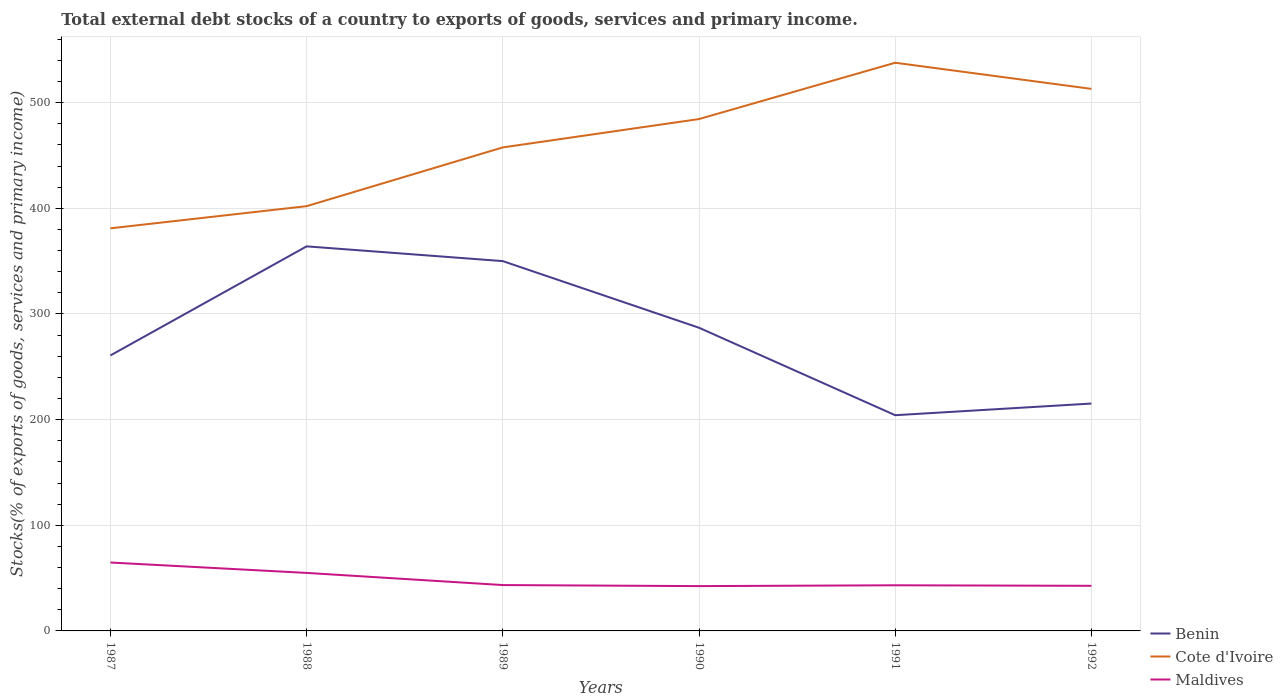How many different coloured lines are there?
Your answer should be compact. 3. Across all years, what is the maximum total debt stocks in Maldives?
Offer a very short reply. 42.42. In which year was the total debt stocks in Cote d'Ivoire maximum?
Ensure brevity in your answer.  1987. What is the total total debt stocks in Maldives in the graph?
Keep it short and to the point. -0.28. What is the difference between the highest and the second highest total debt stocks in Maldives?
Make the answer very short. 22.32. What is the difference between the highest and the lowest total debt stocks in Benin?
Offer a very short reply. 3. Is the total debt stocks in Maldives strictly greater than the total debt stocks in Cote d'Ivoire over the years?
Make the answer very short. Yes. How many lines are there?
Your answer should be compact. 3. Are the values on the major ticks of Y-axis written in scientific E-notation?
Offer a terse response. No. Does the graph contain any zero values?
Your response must be concise. No. Does the graph contain grids?
Give a very brief answer. Yes. Where does the legend appear in the graph?
Your response must be concise. Bottom right. How many legend labels are there?
Ensure brevity in your answer.  3. How are the legend labels stacked?
Offer a terse response. Vertical. What is the title of the graph?
Keep it short and to the point. Total external debt stocks of a country to exports of goods, services and primary income. What is the label or title of the Y-axis?
Make the answer very short. Stocks(% of exports of goods, services and primary income). What is the Stocks(% of exports of goods, services and primary income) of Benin in 1987?
Make the answer very short. 260.75. What is the Stocks(% of exports of goods, services and primary income) of Cote d'Ivoire in 1987?
Your answer should be very brief. 381.06. What is the Stocks(% of exports of goods, services and primary income) in Maldives in 1987?
Offer a very short reply. 64.74. What is the Stocks(% of exports of goods, services and primary income) in Benin in 1988?
Your answer should be very brief. 363.97. What is the Stocks(% of exports of goods, services and primary income) in Cote d'Ivoire in 1988?
Provide a succinct answer. 402.02. What is the Stocks(% of exports of goods, services and primary income) of Maldives in 1988?
Ensure brevity in your answer.  54.9. What is the Stocks(% of exports of goods, services and primary income) of Benin in 1989?
Offer a terse response. 350.01. What is the Stocks(% of exports of goods, services and primary income) in Cote d'Ivoire in 1989?
Keep it short and to the point. 457.64. What is the Stocks(% of exports of goods, services and primary income) in Maldives in 1989?
Offer a terse response. 43.4. What is the Stocks(% of exports of goods, services and primary income) in Benin in 1990?
Your response must be concise. 286.95. What is the Stocks(% of exports of goods, services and primary income) in Cote d'Ivoire in 1990?
Keep it short and to the point. 484.46. What is the Stocks(% of exports of goods, services and primary income) of Maldives in 1990?
Offer a terse response. 42.42. What is the Stocks(% of exports of goods, services and primary income) of Benin in 1991?
Make the answer very short. 204.17. What is the Stocks(% of exports of goods, services and primary income) in Cote d'Ivoire in 1991?
Provide a succinct answer. 537.76. What is the Stocks(% of exports of goods, services and primary income) of Maldives in 1991?
Keep it short and to the point. 43.2. What is the Stocks(% of exports of goods, services and primary income) in Benin in 1992?
Keep it short and to the point. 215.21. What is the Stocks(% of exports of goods, services and primary income) in Cote d'Ivoire in 1992?
Give a very brief answer. 513.04. What is the Stocks(% of exports of goods, services and primary income) in Maldives in 1992?
Make the answer very short. 42.7. Across all years, what is the maximum Stocks(% of exports of goods, services and primary income) of Benin?
Provide a succinct answer. 363.97. Across all years, what is the maximum Stocks(% of exports of goods, services and primary income) of Cote d'Ivoire?
Your answer should be compact. 537.76. Across all years, what is the maximum Stocks(% of exports of goods, services and primary income) in Maldives?
Make the answer very short. 64.74. Across all years, what is the minimum Stocks(% of exports of goods, services and primary income) in Benin?
Offer a very short reply. 204.17. Across all years, what is the minimum Stocks(% of exports of goods, services and primary income) of Cote d'Ivoire?
Give a very brief answer. 381.06. Across all years, what is the minimum Stocks(% of exports of goods, services and primary income) in Maldives?
Provide a short and direct response. 42.42. What is the total Stocks(% of exports of goods, services and primary income) of Benin in the graph?
Your response must be concise. 1681.06. What is the total Stocks(% of exports of goods, services and primary income) in Cote d'Ivoire in the graph?
Provide a succinct answer. 2775.98. What is the total Stocks(% of exports of goods, services and primary income) of Maldives in the graph?
Keep it short and to the point. 291.36. What is the difference between the Stocks(% of exports of goods, services and primary income) of Benin in 1987 and that in 1988?
Make the answer very short. -103.22. What is the difference between the Stocks(% of exports of goods, services and primary income) in Cote d'Ivoire in 1987 and that in 1988?
Your answer should be compact. -20.96. What is the difference between the Stocks(% of exports of goods, services and primary income) of Maldives in 1987 and that in 1988?
Make the answer very short. 9.83. What is the difference between the Stocks(% of exports of goods, services and primary income) in Benin in 1987 and that in 1989?
Ensure brevity in your answer.  -89.26. What is the difference between the Stocks(% of exports of goods, services and primary income) of Cote d'Ivoire in 1987 and that in 1989?
Provide a succinct answer. -76.58. What is the difference between the Stocks(% of exports of goods, services and primary income) of Maldives in 1987 and that in 1989?
Your response must be concise. 21.33. What is the difference between the Stocks(% of exports of goods, services and primary income) in Benin in 1987 and that in 1990?
Provide a short and direct response. -26.19. What is the difference between the Stocks(% of exports of goods, services and primary income) of Cote d'Ivoire in 1987 and that in 1990?
Give a very brief answer. -103.4. What is the difference between the Stocks(% of exports of goods, services and primary income) in Maldives in 1987 and that in 1990?
Offer a terse response. 22.32. What is the difference between the Stocks(% of exports of goods, services and primary income) of Benin in 1987 and that in 1991?
Offer a very short reply. 56.58. What is the difference between the Stocks(% of exports of goods, services and primary income) of Cote d'Ivoire in 1987 and that in 1991?
Ensure brevity in your answer.  -156.7. What is the difference between the Stocks(% of exports of goods, services and primary income) in Maldives in 1987 and that in 1991?
Offer a terse response. 21.54. What is the difference between the Stocks(% of exports of goods, services and primary income) of Benin in 1987 and that in 1992?
Your answer should be very brief. 45.55. What is the difference between the Stocks(% of exports of goods, services and primary income) of Cote d'Ivoire in 1987 and that in 1992?
Offer a very short reply. -131.98. What is the difference between the Stocks(% of exports of goods, services and primary income) of Maldives in 1987 and that in 1992?
Your response must be concise. 22.04. What is the difference between the Stocks(% of exports of goods, services and primary income) in Benin in 1988 and that in 1989?
Make the answer very short. 13.96. What is the difference between the Stocks(% of exports of goods, services and primary income) of Cote d'Ivoire in 1988 and that in 1989?
Make the answer very short. -55.62. What is the difference between the Stocks(% of exports of goods, services and primary income) of Maldives in 1988 and that in 1989?
Your answer should be compact. 11.5. What is the difference between the Stocks(% of exports of goods, services and primary income) in Benin in 1988 and that in 1990?
Your answer should be very brief. 77.02. What is the difference between the Stocks(% of exports of goods, services and primary income) of Cote d'Ivoire in 1988 and that in 1990?
Your answer should be very brief. -82.44. What is the difference between the Stocks(% of exports of goods, services and primary income) of Maldives in 1988 and that in 1990?
Ensure brevity in your answer.  12.48. What is the difference between the Stocks(% of exports of goods, services and primary income) in Benin in 1988 and that in 1991?
Your answer should be compact. 159.8. What is the difference between the Stocks(% of exports of goods, services and primary income) in Cote d'Ivoire in 1988 and that in 1991?
Ensure brevity in your answer.  -135.74. What is the difference between the Stocks(% of exports of goods, services and primary income) of Maldives in 1988 and that in 1991?
Offer a very short reply. 11.71. What is the difference between the Stocks(% of exports of goods, services and primary income) in Benin in 1988 and that in 1992?
Keep it short and to the point. 148.76. What is the difference between the Stocks(% of exports of goods, services and primary income) of Cote d'Ivoire in 1988 and that in 1992?
Offer a terse response. -111.02. What is the difference between the Stocks(% of exports of goods, services and primary income) of Maldives in 1988 and that in 1992?
Your answer should be very brief. 12.21. What is the difference between the Stocks(% of exports of goods, services and primary income) of Benin in 1989 and that in 1990?
Ensure brevity in your answer.  63.06. What is the difference between the Stocks(% of exports of goods, services and primary income) of Cote d'Ivoire in 1989 and that in 1990?
Keep it short and to the point. -26.83. What is the difference between the Stocks(% of exports of goods, services and primary income) in Maldives in 1989 and that in 1990?
Ensure brevity in your answer.  0.98. What is the difference between the Stocks(% of exports of goods, services and primary income) of Benin in 1989 and that in 1991?
Offer a very short reply. 145.84. What is the difference between the Stocks(% of exports of goods, services and primary income) in Cote d'Ivoire in 1989 and that in 1991?
Give a very brief answer. -80.12. What is the difference between the Stocks(% of exports of goods, services and primary income) of Maldives in 1989 and that in 1991?
Offer a very short reply. 0.2. What is the difference between the Stocks(% of exports of goods, services and primary income) in Benin in 1989 and that in 1992?
Provide a short and direct response. 134.8. What is the difference between the Stocks(% of exports of goods, services and primary income) of Cote d'Ivoire in 1989 and that in 1992?
Provide a short and direct response. -55.4. What is the difference between the Stocks(% of exports of goods, services and primary income) of Maldives in 1989 and that in 1992?
Make the answer very short. 0.71. What is the difference between the Stocks(% of exports of goods, services and primary income) in Benin in 1990 and that in 1991?
Your answer should be very brief. 82.78. What is the difference between the Stocks(% of exports of goods, services and primary income) of Cote d'Ivoire in 1990 and that in 1991?
Your response must be concise. -53.3. What is the difference between the Stocks(% of exports of goods, services and primary income) of Maldives in 1990 and that in 1991?
Offer a very short reply. -0.78. What is the difference between the Stocks(% of exports of goods, services and primary income) in Benin in 1990 and that in 1992?
Your response must be concise. 71.74. What is the difference between the Stocks(% of exports of goods, services and primary income) of Cote d'Ivoire in 1990 and that in 1992?
Your answer should be compact. -28.57. What is the difference between the Stocks(% of exports of goods, services and primary income) in Maldives in 1990 and that in 1992?
Ensure brevity in your answer.  -0.28. What is the difference between the Stocks(% of exports of goods, services and primary income) of Benin in 1991 and that in 1992?
Your response must be concise. -11.04. What is the difference between the Stocks(% of exports of goods, services and primary income) of Cote d'Ivoire in 1991 and that in 1992?
Provide a short and direct response. 24.72. What is the difference between the Stocks(% of exports of goods, services and primary income) of Maldives in 1991 and that in 1992?
Give a very brief answer. 0.5. What is the difference between the Stocks(% of exports of goods, services and primary income) in Benin in 1987 and the Stocks(% of exports of goods, services and primary income) in Cote d'Ivoire in 1988?
Offer a very short reply. -141.27. What is the difference between the Stocks(% of exports of goods, services and primary income) in Benin in 1987 and the Stocks(% of exports of goods, services and primary income) in Maldives in 1988?
Give a very brief answer. 205.85. What is the difference between the Stocks(% of exports of goods, services and primary income) of Cote d'Ivoire in 1987 and the Stocks(% of exports of goods, services and primary income) of Maldives in 1988?
Your response must be concise. 326.16. What is the difference between the Stocks(% of exports of goods, services and primary income) in Benin in 1987 and the Stocks(% of exports of goods, services and primary income) in Cote d'Ivoire in 1989?
Give a very brief answer. -196.88. What is the difference between the Stocks(% of exports of goods, services and primary income) in Benin in 1987 and the Stocks(% of exports of goods, services and primary income) in Maldives in 1989?
Offer a terse response. 217.35. What is the difference between the Stocks(% of exports of goods, services and primary income) of Cote d'Ivoire in 1987 and the Stocks(% of exports of goods, services and primary income) of Maldives in 1989?
Make the answer very short. 337.66. What is the difference between the Stocks(% of exports of goods, services and primary income) in Benin in 1987 and the Stocks(% of exports of goods, services and primary income) in Cote d'Ivoire in 1990?
Keep it short and to the point. -223.71. What is the difference between the Stocks(% of exports of goods, services and primary income) of Benin in 1987 and the Stocks(% of exports of goods, services and primary income) of Maldives in 1990?
Provide a short and direct response. 218.33. What is the difference between the Stocks(% of exports of goods, services and primary income) of Cote d'Ivoire in 1987 and the Stocks(% of exports of goods, services and primary income) of Maldives in 1990?
Offer a terse response. 338.64. What is the difference between the Stocks(% of exports of goods, services and primary income) in Benin in 1987 and the Stocks(% of exports of goods, services and primary income) in Cote d'Ivoire in 1991?
Your answer should be very brief. -277.01. What is the difference between the Stocks(% of exports of goods, services and primary income) of Benin in 1987 and the Stocks(% of exports of goods, services and primary income) of Maldives in 1991?
Make the answer very short. 217.55. What is the difference between the Stocks(% of exports of goods, services and primary income) in Cote d'Ivoire in 1987 and the Stocks(% of exports of goods, services and primary income) in Maldives in 1991?
Provide a succinct answer. 337.86. What is the difference between the Stocks(% of exports of goods, services and primary income) of Benin in 1987 and the Stocks(% of exports of goods, services and primary income) of Cote d'Ivoire in 1992?
Keep it short and to the point. -252.28. What is the difference between the Stocks(% of exports of goods, services and primary income) in Benin in 1987 and the Stocks(% of exports of goods, services and primary income) in Maldives in 1992?
Provide a short and direct response. 218.06. What is the difference between the Stocks(% of exports of goods, services and primary income) in Cote d'Ivoire in 1987 and the Stocks(% of exports of goods, services and primary income) in Maldives in 1992?
Offer a terse response. 338.37. What is the difference between the Stocks(% of exports of goods, services and primary income) in Benin in 1988 and the Stocks(% of exports of goods, services and primary income) in Cote d'Ivoire in 1989?
Make the answer very short. -93.67. What is the difference between the Stocks(% of exports of goods, services and primary income) in Benin in 1988 and the Stocks(% of exports of goods, services and primary income) in Maldives in 1989?
Provide a succinct answer. 320.57. What is the difference between the Stocks(% of exports of goods, services and primary income) in Cote d'Ivoire in 1988 and the Stocks(% of exports of goods, services and primary income) in Maldives in 1989?
Your answer should be very brief. 358.62. What is the difference between the Stocks(% of exports of goods, services and primary income) of Benin in 1988 and the Stocks(% of exports of goods, services and primary income) of Cote d'Ivoire in 1990?
Offer a very short reply. -120.49. What is the difference between the Stocks(% of exports of goods, services and primary income) of Benin in 1988 and the Stocks(% of exports of goods, services and primary income) of Maldives in 1990?
Make the answer very short. 321.55. What is the difference between the Stocks(% of exports of goods, services and primary income) in Cote d'Ivoire in 1988 and the Stocks(% of exports of goods, services and primary income) in Maldives in 1990?
Your response must be concise. 359.6. What is the difference between the Stocks(% of exports of goods, services and primary income) in Benin in 1988 and the Stocks(% of exports of goods, services and primary income) in Cote d'Ivoire in 1991?
Your answer should be compact. -173.79. What is the difference between the Stocks(% of exports of goods, services and primary income) of Benin in 1988 and the Stocks(% of exports of goods, services and primary income) of Maldives in 1991?
Your answer should be very brief. 320.77. What is the difference between the Stocks(% of exports of goods, services and primary income) in Cote d'Ivoire in 1988 and the Stocks(% of exports of goods, services and primary income) in Maldives in 1991?
Offer a terse response. 358.82. What is the difference between the Stocks(% of exports of goods, services and primary income) of Benin in 1988 and the Stocks(% of exports of goods, services and primary income) of Cote d'Ivoire in 1992?
Make the answer very short. -149.07. What is the difference between the Stocks(% of exports of goods, services and primary income) of Benin in 1988 and the Stocks(% of exports of goods, services and primary income) of Maldives in 1992?
Give a very brief answer. 321.27. What is the difference between the Stocks(% of exports of goods, services and primary income) in Cote d'Ivoire in 1988 and the Stocks(% of exports of goods, services and primary income) in Maldives in 1992?
Offer a very short reply. 359.32. What is the difference between the Stocks(% of exports of goods, services and primary income) of Benin in 1989 and the Stocks(% of exports of goods, services and primary income) of Cote d'Ivoire in 1990?
Make the answer very short. -134.45. What is the difference between the Stocks(% of exports of goods, services and primary income) of Benin in 1989 and the Stocks(% of exports of goods, services and primary income) of Maldives in 1990?
Ensure brevity in your answer.  307.59. What is the difference between the Stocks(% of exports of goods, services and primary income) in Cote d'Ivoire in 1989 and the Stocks(% of exports of goods, services and primary income) in Maldives in 1990?
Your answer should be compact. 415.22. What is the difference between the Stocks(% of exports of goods, services and primary income) in Benin in 1989 and the Stocks(% of exports of goods, services and primary income) in Cote d'Ivoire in 1991?
Provide a short and direct response. -187.75. What is the difference between the Stocks(% of exports of goods, services and primary income) in Benin in 1989 and the Stocks(% of exports of goods, services and primary income) in Maldives in 1991?
Your response must be concise. 306.81. What is the difference between the Stocks(% of exports of goods, services and primary income) of Cote d'Ivoire in 1989 and the Stocks(% of exports of goods, services and primary income) of Maldives in 1991?
Your answer should be compact. 414.44. What is the difference between the Stocks(% of exports of goods, services and primary income) of Benin in 1989 and the Stocks(% of exports of goods, services and primary income) of Cote d'Ivoire in 1992?
Offer a very short reply. -163.03. What is the difference between the Stocks(% of exports of goods, services and primary income) of Benin in 1989 and the Stocks(% of exports of goods, services and primary income) of Maldives in 1992?
Your answer should be compact. 307.31. What is the difference between the Stocks(% of exports of goods, services and primary income) of Cote d'Ivoire in 1989 and the Stocks(% of exports of goods, services and primary income) of Maldives in 1992?
Provide a succinct answer. 414.94. What is the difference between the Stocks(% of exports of goods, services and primary income) in Benin in 1990 and the Stocks(% of exports of goods, services and primary income) in Cote d'Ivoire in 1991?
Offer a terse response. -250.81. What is the difference between the Stocks(% of exports of goods, services and primary income) in Benin in 1990 and the Stocks(% of exports of goods, services and primary income) in Maldives in 1991?
Your response must be concise. 243.75. What is the difference between the Stocks(% of exports of goods, services and primary income) in Cote d'Ivoire in 1990 and the Stocks(% of exports of goods, services and primary income) in Maldives in 1991?
Give a very brief answer. 441.27. What is the difference between the Stocks(% of exports of goods, services and primary income) in Benin in 1990 and the Stocks(% of exports of goods, services and primary income) in Cote d'Ivoire in 1992?
Make the answer very short. -226.09. What is the difference between the Stocks(% of exports of goods, services and primary income) in Benin in 1990 and the Stocks(% of exports of goods, services and primary income) in Maldives in 1992?
Your answer should be very brief. 244.25. What is the difference between the Stocks(% of exports of goods, services and primary income) of Cote d'Ivoire in 1990 and the Stocks(% of exports of goods, services and primary income) of Maldives in 1992?
Make the answer very short. 441.77. What is the difference between the Stocks(% of exports of goods, services and primary income) in Benin in 1991 and the Stocks(% of exports of goods, services and primary income) in Cote d'Ivoire in 1992?
Offer a very short reply. -308.87. What is the difference between the Stocks(% of exports of goods, services and primary income) in Benin in 1991 and the Stocks(% of exports of goods, services and primary income) in Maldives in 1992?
Give a very brief answer. 161.47. What is the difference between the Stocks(% of exports of goods, services and primary income) in Cote d'Ivoire in 1991 and the Stocks(% of exports of goods, services and primary income) in Maldives in 1992?
Offer a terse response. 495.06. What is the average Stocks(% of exports of goods, services and primary income) of Benin per year?
Your answer should be very brief. 280.18. What is the average Stocks(% of exports of goods, services and primary income) of Cote d'Ivoire per year?
Your answer should be very brief. 462.66. What is the average Stocks(% of exports of goods, services and primary income) of Maldives per year?
Ensure brevity in your answer.  48.56. In the year 1987, what is the difference between the Stocks(% of exports of goods, services and primary income) of Benin and Stocks(% of exports of goods, services and primary income) of Cote d'Ivoire?
Make the answer very short. -120.31. In the year 1987, what is the difference between the Stocks(% of exports of goods, services and primary income) of Benin and Stocks(% of exports of goods, services and primary income) of Maldives?
Offer a very short reply. 196.02. In the year 1987, what is the difference between the Stocks(% of exports of goods, services and primary income) of Cote d'Ivoire and Stocks(% of exports of goods, services and primary income) of Maldives?
Your response must be concise. 316.32. In the year 1988, what is the difference between the Stocks(% of exports of goods, services and primary income) of Benin and Stocks(% of exports of goods, services and primary income) of Cote d'Ivoire?
Your response must be concise. -38.05. In the year 1988, what is the difference between the Stocks(% of exports of goods, services and primary income) of Benin and Stocks(% of exports of goods, services and primary income) of Maldives?
Keep it short and to the point. 309.07. In the year 1988, what is the difference between the Stocks(% of exports of goods, services and primary income) of Cote d'Ivoire and Stocks(% of exports of goods, services and primary income) of Maldives?
Keep it short and to the point. 347.12. In the year 1989, what is the difference between the Stocks(% of exports of goods, services and primary income) in Benin and Stocks(% of exports of goods, services and primary income) in Cote d'Ivoire?
Ensure brevity in your answer.  -107.63. In the year 1989, what is the difference between the Stocks(% of exports of goods, services and primary income) in Benin and Stocks(% of exports of goods, services and primary income) in Maldives?
Your answer should be very brief. 306.61. In the year 1989, what is the difference between the Stocks(% of exports of goods, services and primary income) in Cote d'Ivoire and Stocks(% of exports of goods, services and primary income) in Maldives?
Provide a short and direct response. 414.23. In the year 1990, what is the difference between the Stocks(% of exports of goods, services and primary income) in Benin and Stocks(% of exports of goods, services and primary income) in Cote d'Ivoire?
Give a very brief answer. -197.52. In the year 1990, what is the difference between the Stocks(% of exports of goods, services and primary income) of Benin and Stocks(% of exports of goods, services and primary income) of Maldives?
Your response must be concise. 244.53. In the year 1990, what is the difference between the Stocks(% of exports of goods, services and primary income) in Cote d'Ivoire and Stocks(% of exports of goods, services and primary income) in Maldives?
Offer a terse response. 442.04. In the year 1991, what is the difference between the Stocks(% of exports of goods, services and primary income) in Benin and Stocks(% of exports of goods, services and primary income) in Cote d'Ivoire?
Keep it short and to the point. -333.59. In the year 1991, what is the difference between the Stocks(% of exports of goods, services and primary income) in Benin and Stocks(% of exports of goods, services and primary income) in Maldives?
Provide a succinct answer. 160.97. In the year 1991, what is the difference between the Stocks(% of exports of goods, services and primary income) in Cote d'Ivoire and Stocks(% of exports of goods, services and primary income) in Maldives?
Provide a succinct answer. 494.56. In the year 1992, what is the difference between the Stocks(% of exports of goods, services and primary income) in Benin and Stocks(% of exports of goods, services and primary income) in Cote d'Ivoire?
Ensure brevity in your answer.  -297.83. In the year 1992, what is the difference between the Stocks(% of exports of goods, services and primary income) of Benin and Stocks(% of exports of goods, services and primary income) of Maldives?
Keep it short and to the point. 172.51. In the year 1992, what is the difference between the Stocks(% of exports of goods, services and primary income) of Cote d'Ivoire and Stocks(% of exports of goods, services and primary income) of Maldives?
Provide a short and direct response. 470.34. What is the ratio of the Stocks(% of exports of goods, services and primary income) in Benin in 1987 to that in 1988?
Keep it short and to the point. 0.72. What is the ratio of the Stocks(% of exports of goods, services and primary income) in Cote d'Ivoire in 1987 to that in 1988?
Keep it short and to the point. 0.95. What is the ratio of the Stocks(% of exports of goods, services and primary income) of Maldives in 1987 to that in 1988?
Your answer should be very brief. 1.18. What is the ratio of the Stocks(% of exports of goods, services and primary income) of Benin in 1987 to that in 1989?
Make the answer very short. 0.74. What is the ratio of the Stocks(% of exports of goods, services and primary income) in Cote d'Ivoire in 1987 to that in 1989?
Your answer should be very brief. 0.83. What is the ratio of the Stocks(% of exports of goods, services and primary income) in Maldives in 1987 to that in 1989?
Your answer should be compact. 1.49. What is the ratio of the Stocks(% of exports of goods, services and primary income) in Benin in 1987 to that in 1990?
Keep it short and to the point. 0.91. What is the ratio of the Stocks(% of exports of goods, services and primary income) of Cote d'Ivoire in 1987 to that in 1990?
Offer a very short reply. 0.79. What is the ratio of the Stocks(% of exports of goods, services and primary income) in Maldives in 1987 to that in 1990?
Your answer should be very brief. 1.53. What is the ratio of the Stocks(% of exports of goods, services and primary income) of Benin in 1987 to that in 1991?
Offer a very short reply. 1.28. What is the ratio of the Stocks(% of exports of goods, services and primary income) in Cote d'Ivoire in 1987 to that in 1991?
Ensure brevity in your answer.  0.71. What is the ratio of the Stocks(% of exports of goods, services and primary income) in Maldives in 1987 to that in 1991?
Your response must be concise. 1.5. What is the ratio of the Stocks(% of exports of goods, services and primary income) of Benin in 1987 to that in 1992?
Offer a very short reply. 1.21. What is the ratio of the Stocks(% of exports of goods, services and primary income) of Cote d'Ivoire in 1987 to that in 1992?
Offer a very short reply. 0.74. What is the ratio of the Stocks(% of exports of goods, services and primary income) in Maldives in 1987 to that in 1992?
Your answer should be very brief. 1.52. What is the ratio of the Stocks(% of exports of goods, services and primary income) of Benin in 1988 to that in 1989?
Ensure brevity in your answer.  1.04. What is the ratio of the Stocks(% of exports of goods, services and primary income) in Cote d'Ivoire in 1988 to that in 1989?
Make the answer very short. 0.88. What is the ratio of the Stocks(% of exports of goods, services and primary income) in Maldives in 1988 to that in 1989?
Your response must be concise. 1.26. What is the ratio of the Stocks(% of exports of goods, services and primary income) of Benin in 1988 to that in 1990?
Your response must be concise. 1.27. What is the ratio of the Stocks(% of exports of goods, services and primary income) in Cote d'Ivoire in 1988 to that in 1990?
Offer a very short reply. 0.83. What is the ratio of the Stocks(% of exports of goods, services and primary income) of Maldives in 1988 to that in 1990?
Your response must be concise. 1.29. What is the ratio of the Stocks(% of exports of goods, services and primary income) in Benin in 1988 to that in 1991?
Provide a succinct answer. 1.78. What is the ratio of the Stocks(% of exports of goods, services and primary income) of Cote d'Ivoire in 1988 to that in 1991?
Ensure brevity in your answer.  0.75. What is the ratio of the Stocks(% of exports of goods, services and primary income) in Maldives in 1988 to that in 1991?
Provide a succinct answer. 1.27. What is the ratio of the Stocks(% of exports of goods, services and primary income) in Benin in 1988 to that in 1992?
Your answer should be very brief. 1.69. What is the ratio of the Stocks(% of exports of goods, services and primary income) in Cote d'Ivoire in 1988 to that in 1992?
Your answer should be very brief. 0.78. What is the ratio of the Stocks(% of exports of goods, services and primary income) in Maldives in 1988 to that in 1992?
Keep it short and to the point. 1.29. What is the ratio of the Stocks(% of exports of goods, services and primary income) of Benin in 1989 to that in 1990?
Offer a very short reply. 1.22. What is the ratio of the Stocks(% of exports of goods, services and primary income) of Cote d'Ivoire in 1989 to that in 1990?
Your answer should be compact. 0.94. What is the ratio of the Stocks(% of exports of goods, services and primary income) of Maldives in 1989 to that in 1990?
Ensure brevity in your answer.  1.02. What is the ratio of the Stocks(% of exports of goods, services and primary income) of Benin in 1989 to that in 1991?
Provide a short and direct response. 1.71. What is the ratio of the Stocks(% of exports of goods, services and primary income) of Cote d'Ivoire in 1989 to that in 1991?
Provide a short and direct response. 0.85. What is the ratio of the Stocks(% of exports of goods, services and primary income) in Benin in 1989 to that in 1992?
Offer a very short reply. 1.63. What is the ratio of the Stocks(% of exports of goods, services and primary income) of Cote d'Ivoire in 1989 to that in 1992?
Provide a short and direct response. 0.89. What is the ratio of the Stocks(% of exports of goods, services and primary income) of Maldives in 1989 to that in 1992?
Keep it short and to the point. 1.02. What is the ratio of the Stocks(% of exports of goods, services and primary income) in Benin in 1990 to that in 1991?
Offer a terse response. 1.41. What is the ratio of the Stocks(% of exports of goods, services and primary income) in Cote d'Ivoire in 1990 to that in 1991?
Offer a terse response. 0.9. What is the ratio of the Stocks(% of exports of goods, services and primary income) of Cote d'Ivoire in 1990 to that in 1992?
Ensure brevity in your answer.  0.94. What is the ratio of the Stocks(% of exports of goods, services and primary income) of Benin in 1991 to that in 1992?
Your answer should be compact. 0.95. What is the ratio of the Stocks(% of exports of goods, services and primary income) in Cote d'Ivoire in 1991 to that in 1992?
Your answer should be very brief. 1.05. What is the ratio of the Stocks(% of exports of goods, services and primary income) in Maldives in 1991 to that in 1992?
Your answer should be very brief. 1.01. What is the difference between the highest and the second highest Stocks(% of exports of goods, services and primary income) of Benin?
Your answer should be compact. 13.96. What is the difference between the highest and the second highest Stocks(% of exports of goods, services and primary income) in Cote d'Ivoire?
Ensure brevity in your answer.  24.72. What is the difference between the highest and the second highest Stocks(% of exports of goods, services and primary income) of Maldives?
Your answer should be very brief. 9.83. What is the difference between the highest and the lowest Stocks(% of exports of goods, services and primary income) of Benin?
Provide a short and direct response. 159.8. What is the difference between the highest and the lowest Stocks(% of exports of goods, services and primary income) of Cote d'Ivoire?
Make the answer very short. 156.7. What is the difference between the highest and the lowest Stocks(% of exports of goods, services and primary income) of Maldives?
Your answer should be compact. 22.32. 